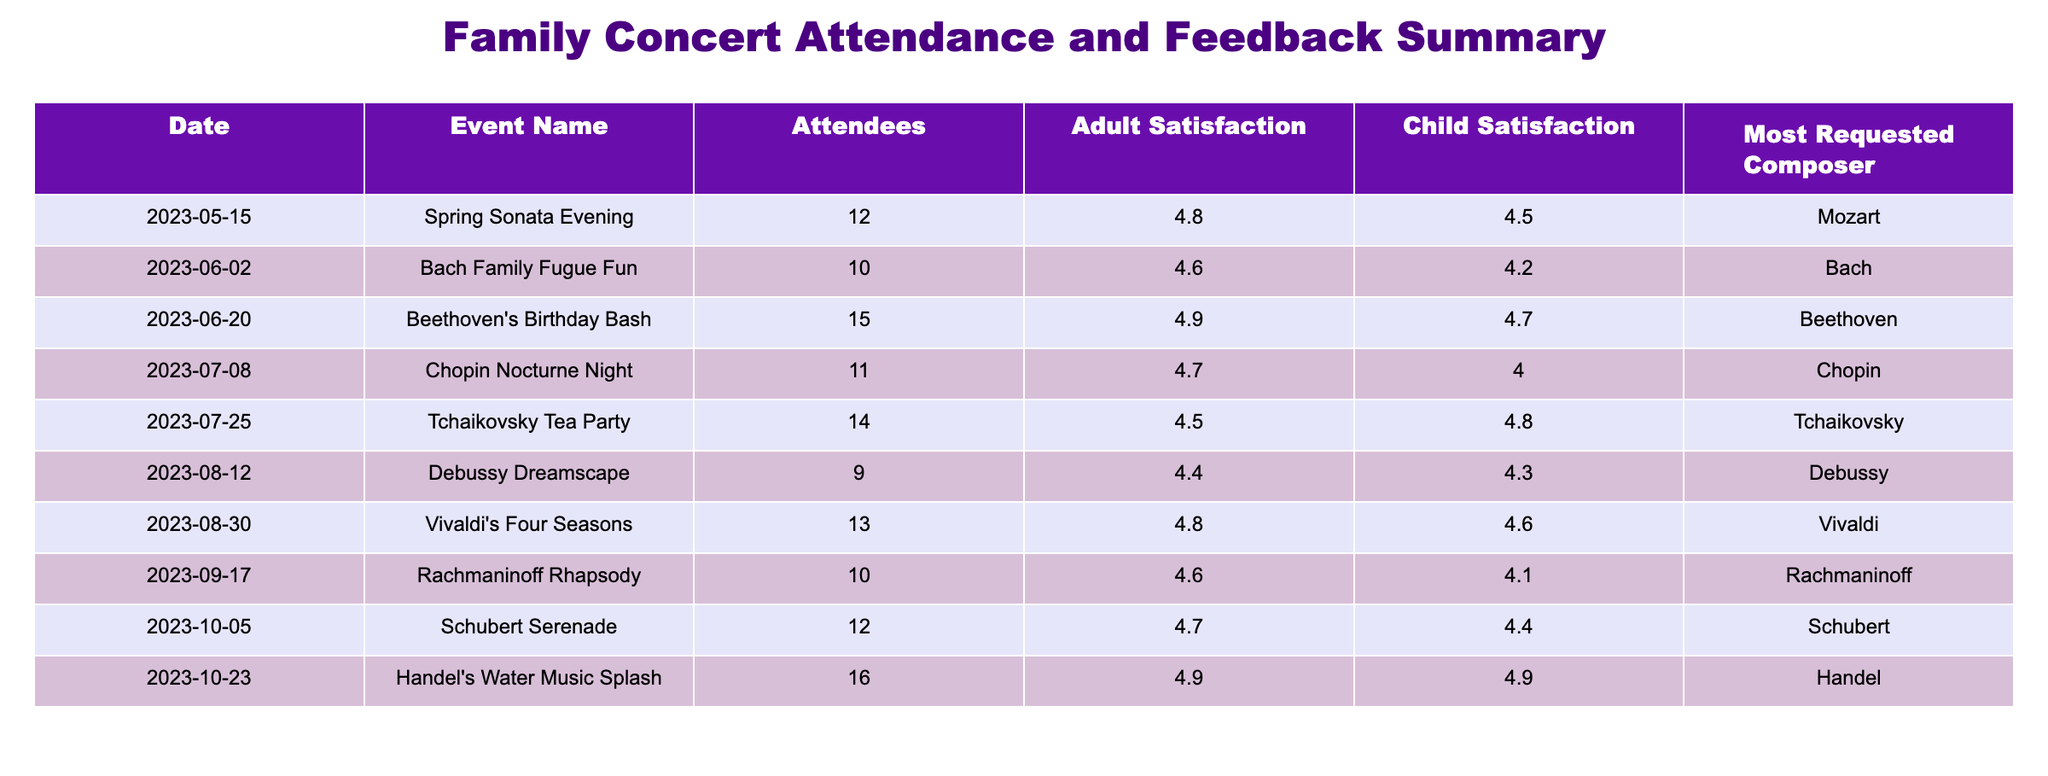What is the most requested composer during the concerts? By looking at the "Most Requested Composer" column in the table, I can see that the names of the composers listed are Mozart, Bach, Beethoven, Chopin, Tchaikovsky, Debussy, Vivaldi, Rachmaninoff, Schubert, and Handel. Since there is no repetition and each composer is unique to their respective event, there is not a single most requested composer overall. However, the last concert listed indicates Handel as the most requested composer for that specific event.
Answer: Handel Which event had the highest adult satisfaction rating? In the "Adult Satisfaction" column, the ratings are 4.8, 4.6, 4.9, 4.7, 4.5, 4.4, 4.8, 4.6, 4.7, and 4.9. The highest rating of 4.9 can be found in two events: "Beethoven's Birthday Bash" and "Handel's Water Music Splash".
Answer: Beethoven's Birthday Bash and Handel's Water Music Splash What was the average child satisfaction rating across all events? To find the average child satisfaction, I will sum all child satisfaction ratings: (4.5 + 4.2 + 4.7 + 4.0 + 4.8 + 4.3 + 4.6 + 4.1 + 4.4 + 4.9) = 46.7. Then, I divide 46.7 by the number of events, which is 10. The average is therefore 46.7 / 10 = 4.67.
Answer: 4.67 Did more adults or children express satisfaction at the "Tchaikovsky Tea Party"? For the "Tchaikovsky Tea Party," the adult satisfaction rating is 4.5 and child satisfaction is 4.8. Comparing both, the child satisfaction (4.8) is higher than the adult satisfaction (4.5), indicating that more children expressed satisfaction at this specific event.
Answer: Children What is the difference between the highest and lowest number of attendees across all events? The highest number of attendees is 16 from "Handel's Water Music Splash," while the lowest is 9 from "Debussy Dreamscape." To find the difference, I subtract the lowest from the highest: 16 - 9 = 7.
Answer: 7 Which event had the lowest child satisfaction rating, and what was it? Looking at the "Child Satisfaction" column, the ratings are 4.5, 4.2, 4.7, 4.0, 4.8, 4.3, 4.6, 4.1, 4.4, and 4.9. The lowest rating is 4.0, which belongs to the "Chopin Nocturne Night."
Answer: Chopin Nocturne Night, 4.0 How many events had an adult satisfaction rating of 4.7 or greater? The adult satisfaction ratings listed are 4.8, 4.6, 4.9, 4.7, 4.5, 4.4, 4.8, 4.6, 4.7, and 4.9. The ratings of 4.7 or greater are 4.8 (2 events), 4.9 (3 events), and 4.7 (2 events). Adding these gives a total of 7 events.
Answer: 7 What percentage of the events had more than 12 attendees? The events with more than 12 attendees are "Beethoven's Birthday Bash" (15), "Tchaikovsky Tea Party" (14), and "Handel's Water Music Splash" (16), totaling 3 out of 10 events. To find the percentage, I calculate (3 / 10) * 100 = 30%.
Answer: 30% 